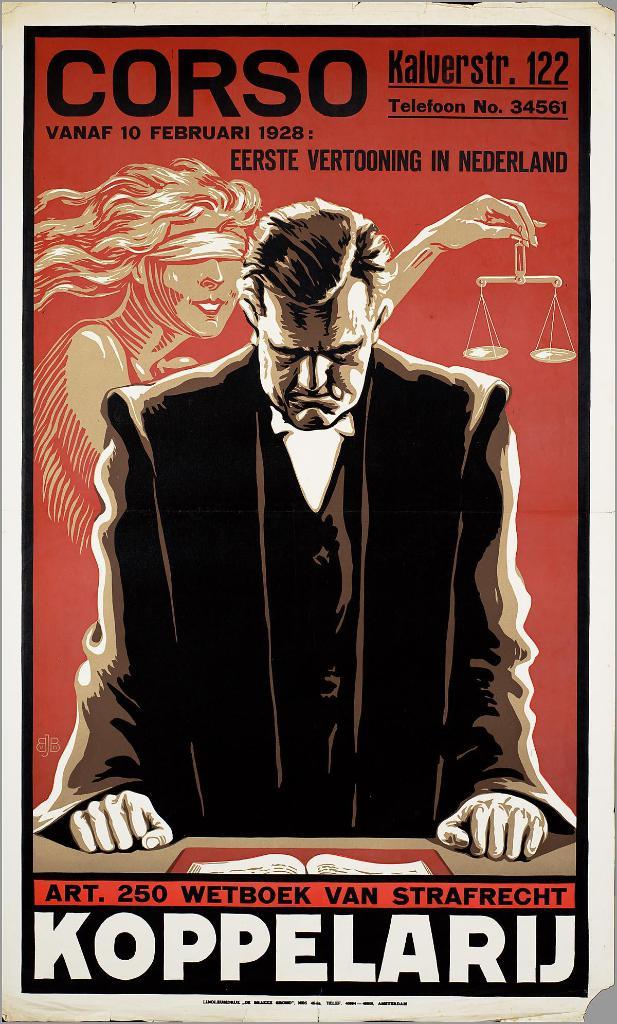What's the name at the top left?
Offer a terse response. Corso. What is the name at the bottom?
Your response must be concise. Koppelarij. 